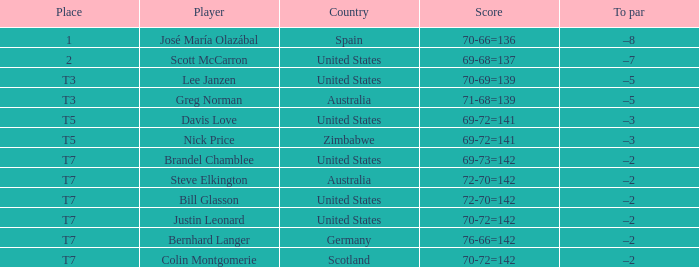Who is the Player with a Score of 70-72=142? Question 3 Justin Leonard, Colin Montgomerie. 